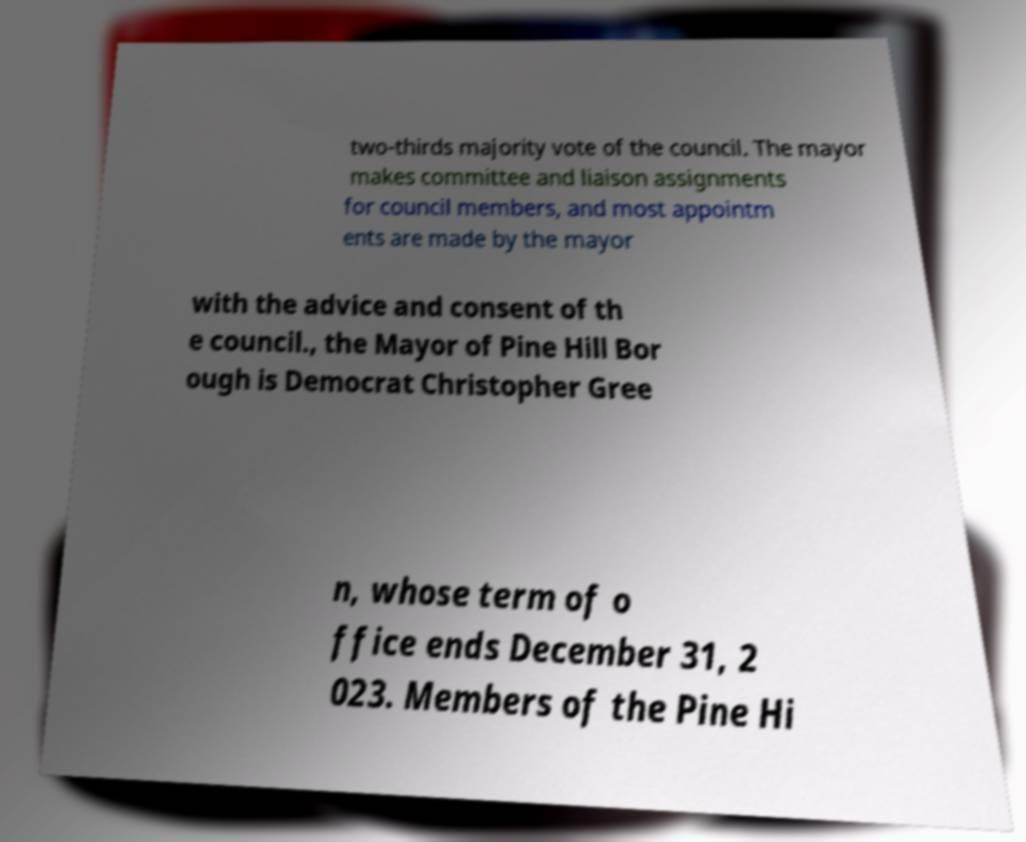I need the written content from this picture converted into text. Can you do that? two-thirds majority vote of the council. The mayor makes committee and liaison assignments for council members, and most appointm ents are made by the mayor with the advice and consent of th e council., the Mayor of Pine Hill Bor ough is Democrat Christopher Gree n, whose term of o ffice ends December 31, 2 023. Members of the Pine Hi 